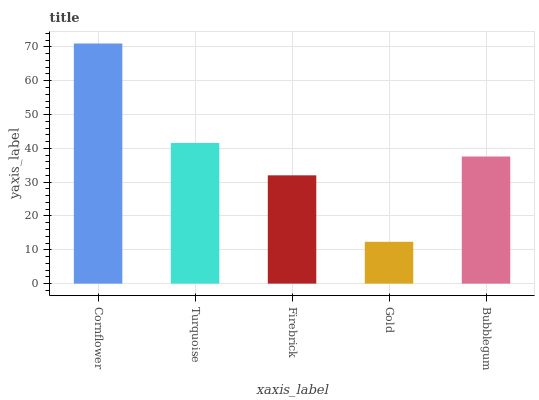Is Gold the minimum?
Answer yes or no. Yes. Is Cornflower the maximum?
Answer yes or no. Yes. Is Turquoise the minimum?
Answer yes or no. No. Is Turquoise the maximum?
Answer yes or no. No. Is Cornflower greater than Turquoise?
Answer yes or no. Yes. Is Turquoise less than Cornflower?
Answer yes or no. Yes. Is Turquoise greater than Cornflower?
Answer yes or no. No. Is Cornflower less than Turquoise?
Answer yes or no. No. Is Bubblegum the high median?
Answer yes or no. Yes. Is Bubblegum the low median?
Answer yes or no. Yes. Is Cornflower the high median?
Answer yes or no. No. Is Cornflower the low median?
Answer yes or no. No. 